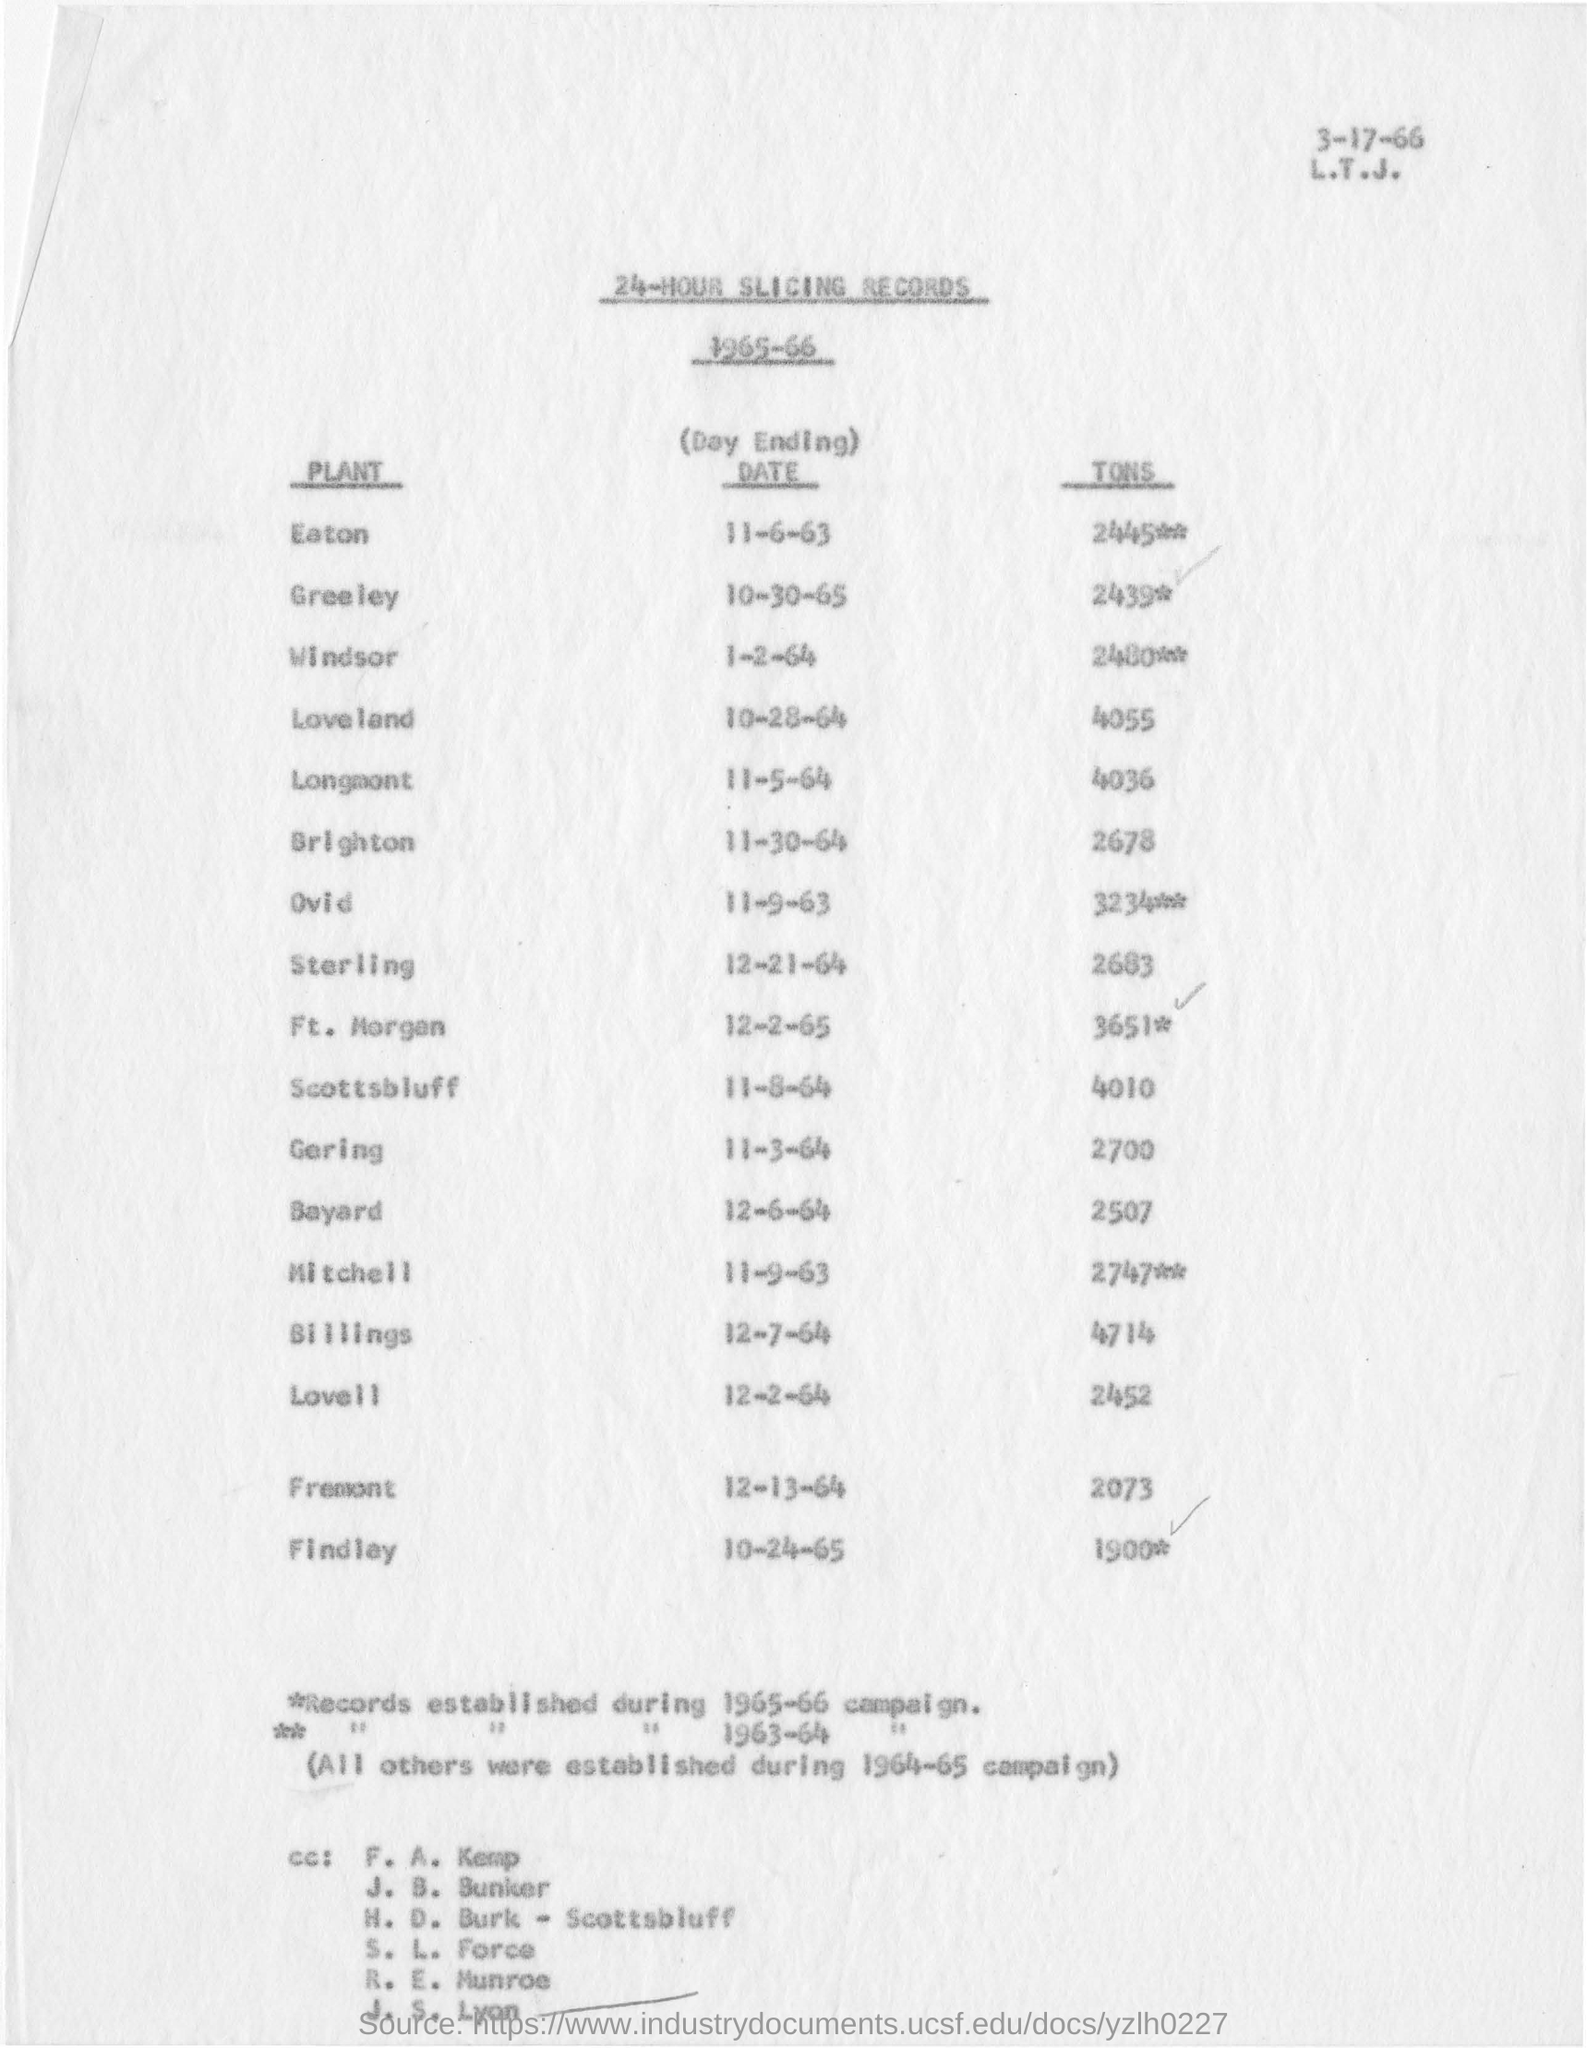Point out several critical features in this image. On June 11th, 1963, the ending date of Which Plant's Day was EATON. The date of Sterling is December 21, 1964. The date mentioned at the top is 3-17-66. 